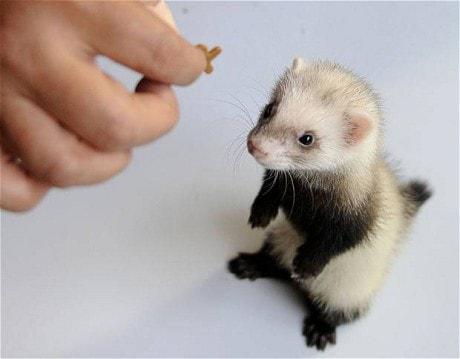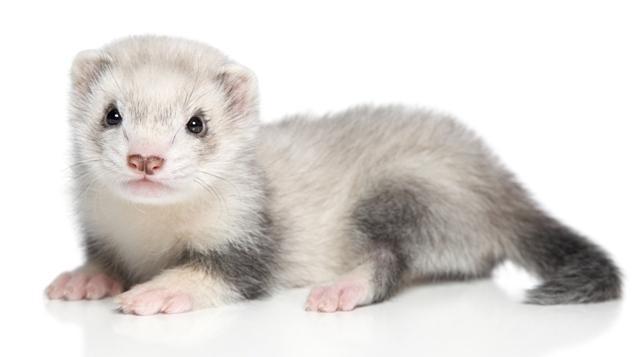The first image is the image on the left, the second image is the image on the right. Given the left and right images, does the statement "There is exactly one human hand next to at least one upright ferret." hold true? Answer yes or no. Yes. The first image is the image on the left, the second image is the image on the right. Examine the images to the left and right. Is the description "There is exactly two ferrets." accurate? Answer yes or no. Yes. 